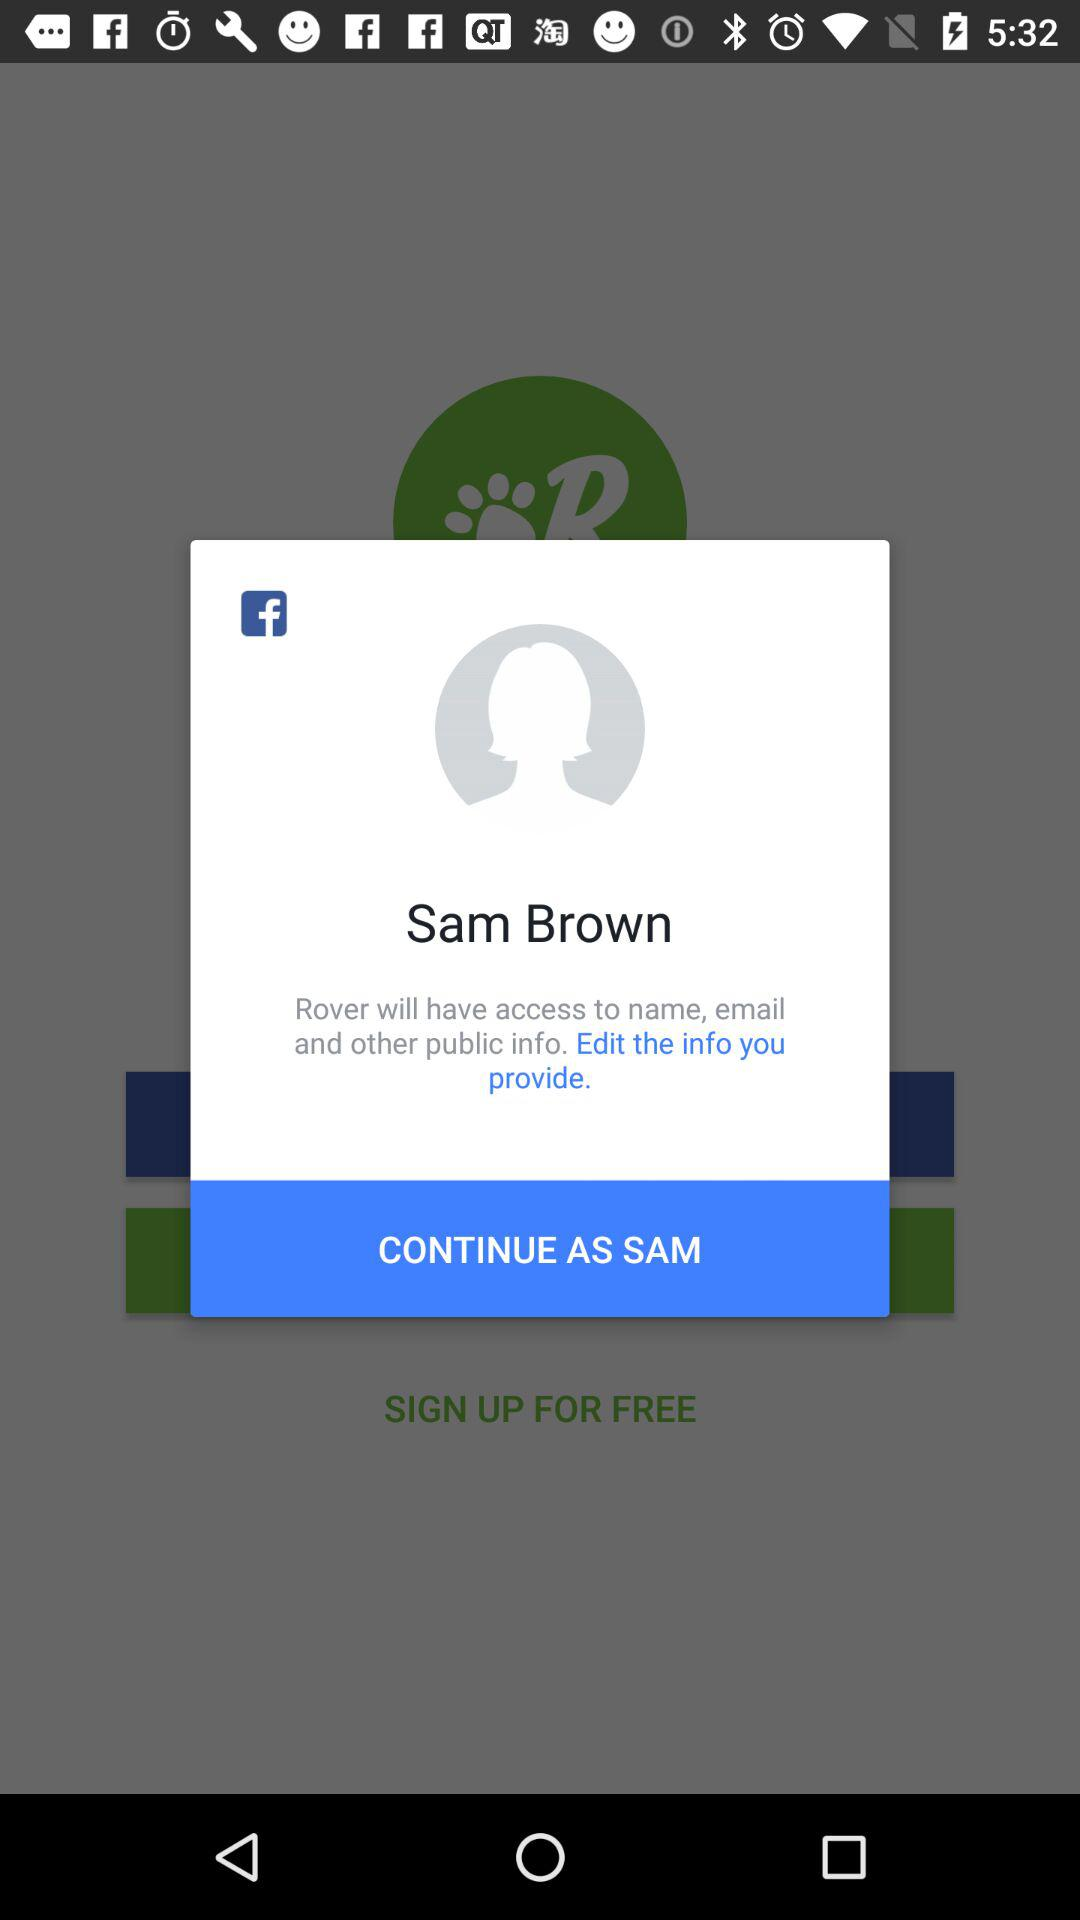What application will have access to name, email and other public info? The application is "Rover". 